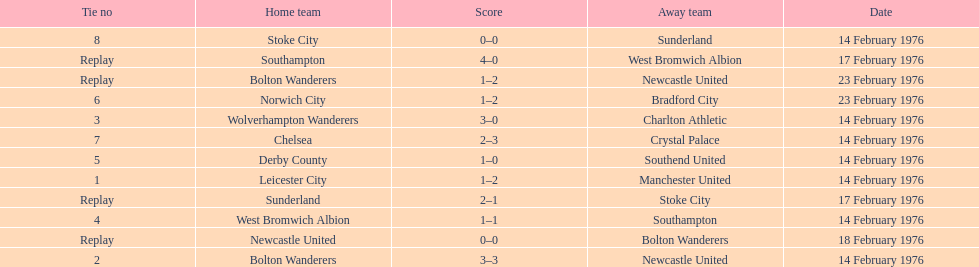What is the difference between southampton's score and sunderland's score? 2 goals. 